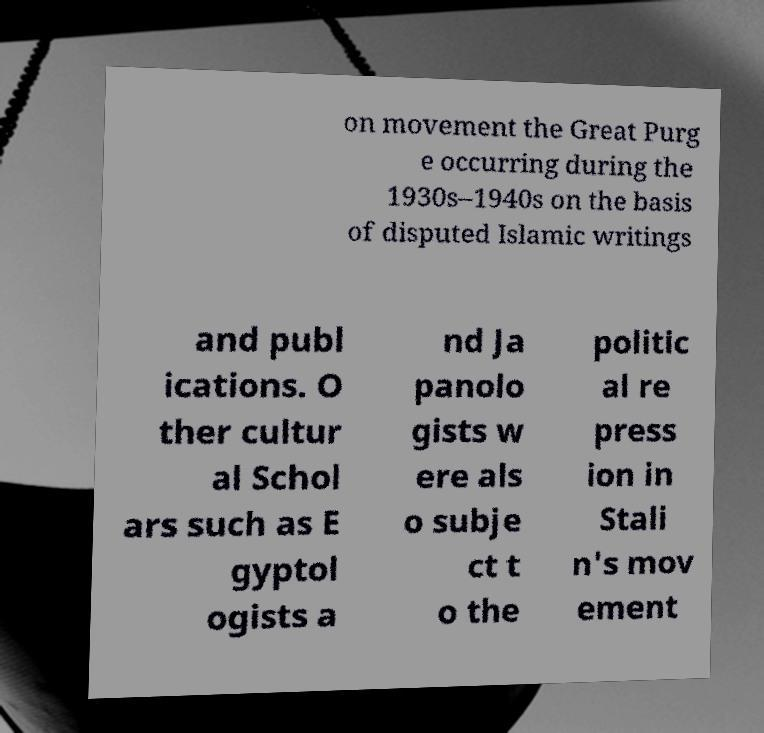Can you explain more about the 'Great Purge' mentioned in this image? The 'Great Purge,' also known as the Great Terror, was a campaign of political repression in the Soviet Union during the late 1930s, orchestrated by Joseph Stalin. It involved a large-scale purge of the Communist Party and government officials, repression of peasants and the Red Army leadership, widespread police surveillance, suspicion of saboteurs, counter-revolutionaries, imprisonment, and arbitrary executions. 